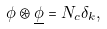<formula> <loc_0><loc_0><loc_500><loc_500>\phi \circledast \underline { \phi } = N _ { c } \delta _ { k } ,</formula> 